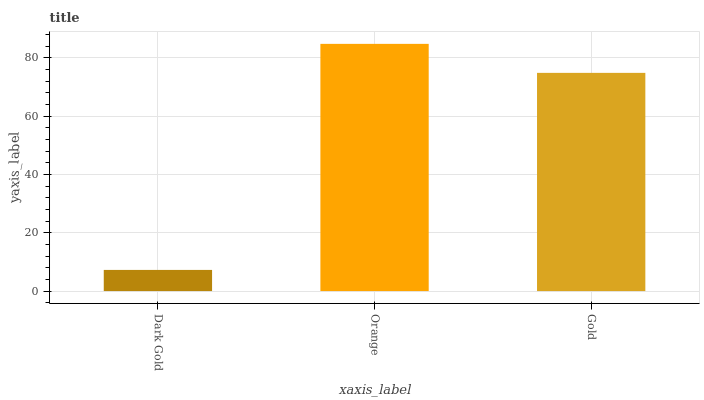Is Dark Gold the minimum?
Answer yes or no. Yes. Is Orange the maximum?
Answer yes or no. Yes. Is Gold the minimum?
Answer yes or no. No. Is Gold the maximum?
Answer yes or no. No. Is Orange greater than Gold?
Answer yes or no. Yes. Is Gold less than Orange?
Answer yes or no. Yes. Is Gold greater than Orange?
Answer yes or no. No. Is Orange less than Gold?
Answer yes or no. No. Is Gold the high median?
Answer yes or no. Yes. Is Gold the low median?
Answer yes or no. Yes. Is Dark Gold the high median?
Answer yes or no. No. Is Dark Gold the low median?
Answer yes or no. No. 